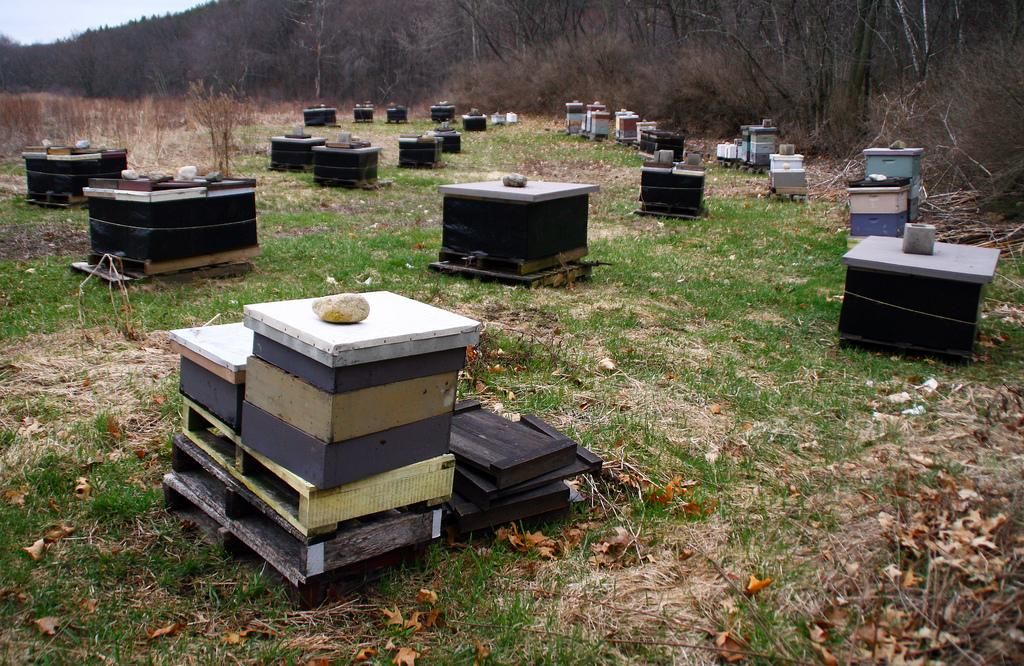What type of objects are visible in the image? There are wooden boxes in the image. Where are the wooden boxes located? The wooden boxes are on a grass surface. What can be seen behind the wooden boxes? There are dry plants and trees behind the boxes. What type of prose can be read on the wooden boxes in the image? There is no prose present on the wooden boxes in the image. What shape are the wooden boxes in the image? The provided facts do not mention the shape of the wooden boxes, so we cannot determine their shape from the image. 